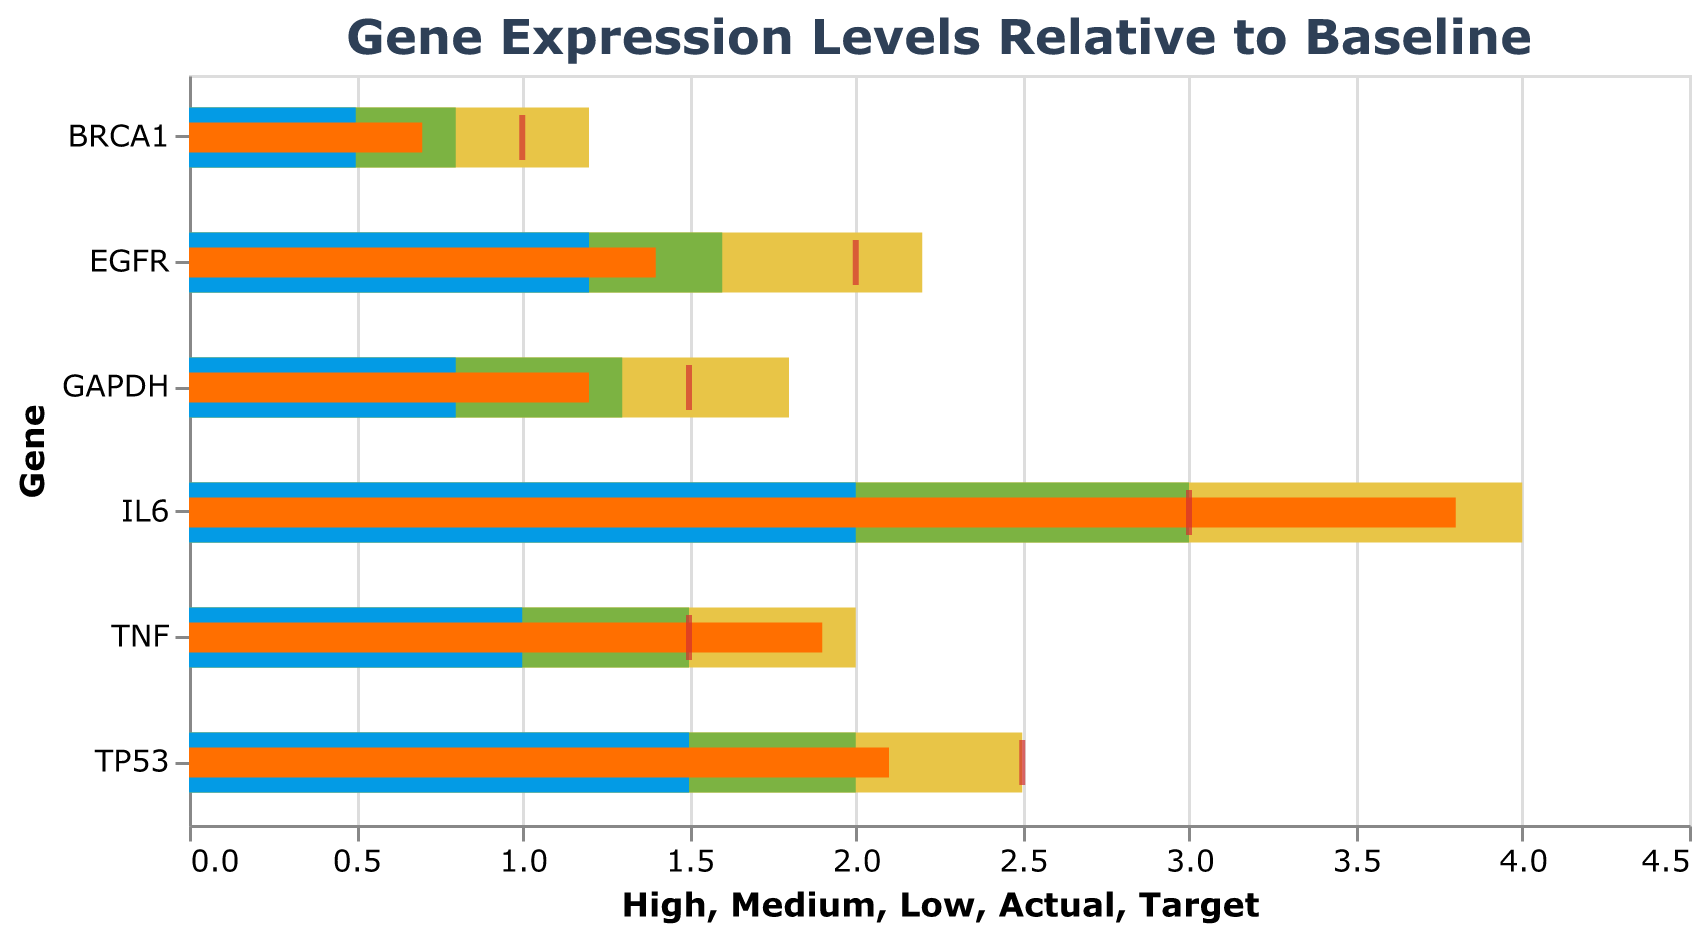What is the title of the chart? The title of the chart is usually located at the top and provides a quick summary of what the chart is about. Here, it states "Gene Expression Levels Relative to Baseline"
Answer: Gene Expression Levels Relative to Baseline Which gene has the highest actual expression level? To find the gene with the highest actual expression level, look for the gene with the tallest orange bar (representing actual expression). The gene with the tallest orange bar is IL6 with an actual expression level of 3.8.
Answer: IL6 What is the target expression level for BRCA1? The target expression level is represented by the red tick mark on the chart. For BRCA1, the red tick mark is at the 1.0 mark.
Answer: 1.0 Which gene's actual expression level is closest to its target? To find the gene with the actual expression level closest to its target, compare the orange bars (actual) to the red ticks (target). GAPDH has an actual of 1.2 and a target of 1.5, which is a difference of 0.3. GAPDH's difference from target is smallest among all genes.
Answer: GAPDH How many genes have a high expression level range (represented by the yellow bar) that exceeds 2.0? The high expression range is shown by the length of the yellow bar. Count the number of genes with yellow bars extending beyond the 2.0 mark. Here, only IL6 and TP53 have their yellow bars exceeding 2.0.
Answer: 2 What is the difference between the actual expression levels of GAPDH and BRCA1? Subtract the actual value of BRCA1 from the actual value of GAPDH: 1.2 - 0.7 = 0.5
Answer: 0.5 Which gene's actual expression level significantly exceeds its high range? Compare the actual levels (orange bars) with the high range limits (ends of yellow bars). IL6's actual expression (3.8) is considerably higher than its high range (4.0). Since this value is beyond the specified range, it’s noticeable.
Answer: IL6 Which gene has the lowest target expression level? Look at the position of the red ticks along the x-axis. The gene with the red tick farthest to the left is BRCA1 with a target expression level of 1.0.
Answer: BRCA1 How does the actual expression level of TNF compare to its target? Compare the orange bar (actual) for TNF to its red tick (target). TNF's actual expression is 1.9 while its target is 1.5. This indicates that TNF's actual level is 0.4 units higher than its target.
Answer: 0.4 units higher 